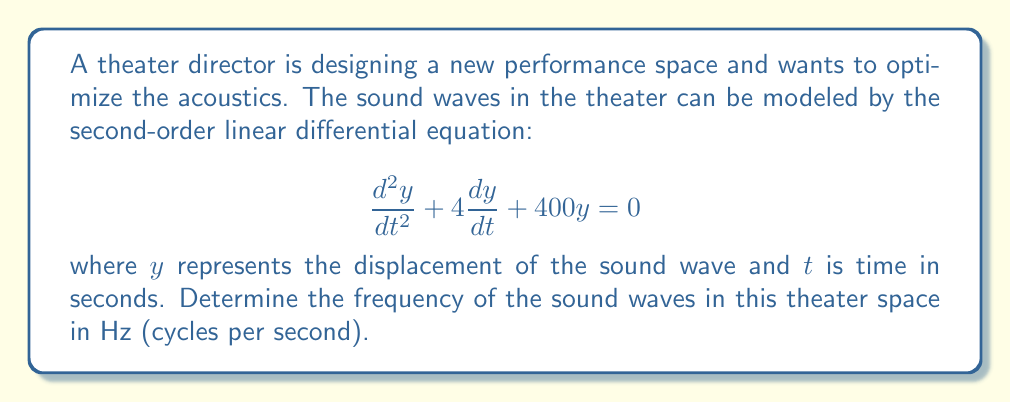Could you help me with this problem? To find the frequency of the sound waves, we need to solve the given differential equation and analyze its solution. Let's approach this step-by-step:

1) The general form of a second-order linear differential equation is:

   $$\frac{d^2y}{dt^2} + 2\zeta\omega_n\frac{dy}{dt} + \omega_n^2y = 0$$

   where $\zeta$ is the damping ratio and $\omega_n$ is the natural frequency.

2) Comparing our equation to this general form, we can see that:

   $2\zeta\omega_n = 4$ and $\omega_n^2 = 400$

3) From $\omega_n^2 = 400$, we can find $\omega_n$:

   $\omega_n = \sqrt{400} = 20$ rad/s

4) The damped natural frequency $\omega_d$ is given by:

   $$\omega_d = \omega_n\sqrt{1-\zeta^2}$$

5) To find $\zeta$, we use $2\zeta\omega_n = 4$:

   $2\zeta(20) = 4$
   $\zeta = 0.1$

6) Now we can calculate $\omega_d$:

   $$\omega_d = 20\sqrt{1-0.1^2} = 20\sqrt{0.99} \approx 19.9$ rad/s

7) To convert from angular frequency (rad/s) to frequency in Hz, we use the formula:

   $$f = \frac{\omega_d}{2\pi}$$

8) Substituting our value for $\omega_d$:

   $$f = \frac{19.9}{2\pi} \approx 3.17$ Hz
Answer: The frequency of the sound waves in the theater is approximately 3.17 Hz. 